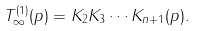<formula> <loc_0><loc_0><loc_500><loc_500>T ^ { ( 1 ) } _ { \infty } ( p ) = K _ { 2 } K _ { 3 } \cdots K _ { n + 1 } ( p ) .</formula> 